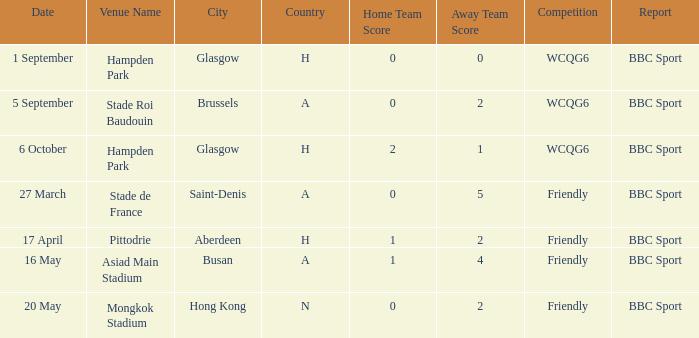What was the score of the game on 1 september? 0–0. 